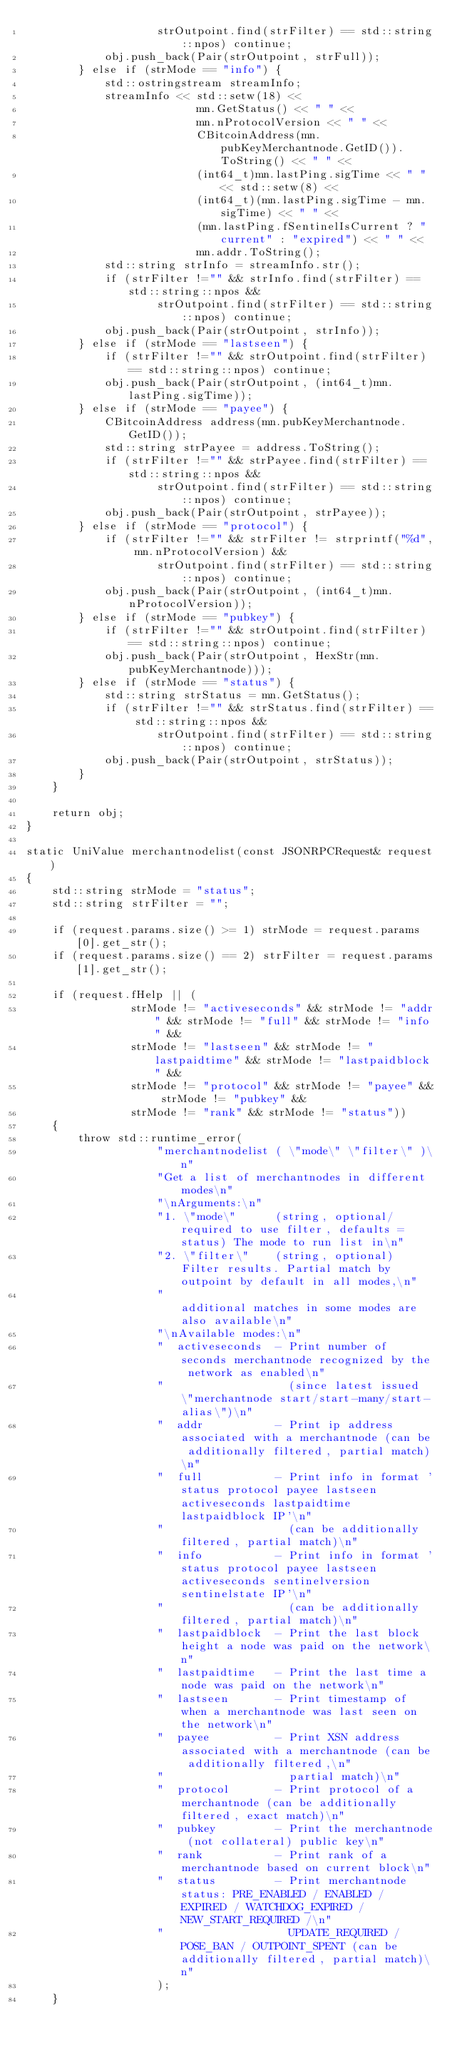<code> <loc_0><loc_0><loc_500><loc_500><_C++_>                    strOutpoint.find(strFilter) == std::string::npos) continue;
            obj.push_back(Pair(strOutpoint, strFull));
        } else if (strMode == "info") {
            std::ostringstream streamInfo;
            streamInfo << std::setw(18) <<
                          mn.GetStatus() << " " <<
                          mn.nProtocolVersion << " " <<
                          CBitcoinAddress(mn.pubKeyMerchantnode.GetID()).ToString() << " " <<
                          (int64_t)mn.lastPing.sigTime << " " << std::setw(8) <<
                          (int64_t)(mn.lastPing.sigTime - mn.sigTime) << " " <<
                          (mn.lastPing.fSentinelIsCurrent ? "current" : "expired") << " " <<
                          mn.addr.ToString();
            std::string strInfo = streamInfo.str();
            if (strFilter !="" && strInfo.find(strFilter) == std::string::npos &&
                    strOutpoint.find(strFilter) == std::string::npos) continue;
            obj.push_back(Pair(strOutpoint, strInfo));
        } else if (strMode == "lastseen") {
            if (strFilter !="" && strOutpoint.find(strFilter) == std::string::npos) continue;
            obj.push_back(Pair(strOutpoint, (int64_t)mn.lastPing.sigTime));
        } else if (strMode == "payee") {
            CBitcoinAddress address(mn.pubKeyMerchantnode.GetID());
            std::string strPayee = address.ToString();
            if (strFilter !="" && strPayee.find(strFilter) == std::string::npos &&
                    strOutpoint.find(strFilter) == std::string::npos) continue;
            obj.push_back(Pair(strOutpoint, strPayee));
        } else if (strMode == "protocol") {
            if (strFilter !="" && strFilter != strprintf("%d", mn.nProtocolVersion) &&
                    strOutpoint.find(strFilter) == std::string::npos) continue;
            obj.push_back(Pair(strOutpoint, (int64_t)mn.nProtocolVersion));
        } else if (strMode == "pubkey") {
            if (strFilter !="" && strOutpoint.find(strFilter) == std::string::npos) continue;
            obj.push_back(Pair(strOutpoint, HexStr(mn.pubKeyMerchantnode)));
        } else if (strMode == "status") {
            std::string strStatus = mn.GetStatus();
            if (strFilter !="" && strStatus.find(strFilter) == std::string::npos &&
                    strOutpoint.find(strFilter) == std::string::npos) continue;
            obj.push_back(Pair(strOutpoint, strStatus));
        }
    }

    return obj;
}

static UniValue merchantnodelist(const JSONRPCRequest& request)
{
    std::string strMode = "status";
    std::string strFilter = "";

    if (request.params.size() >= 1) strMode = request.params[0].get_str();
    if (request.params.size() == 2) strFilter = request.params[1].get_str();

    if (request.fHelp || (
                strMode != "activeseconds" && strMode != "addr" && strMode != "full" && strMode != "info" &&
                strMode != "lastseen" && strMode != "lastpaidtime" && strMode != "lastpaidblock" &&
                strMode != "protocol" && strMode != "payee" && strMode != "pubkey" &&
                strMode != "rank" && strMode != "status"))
    {
        throw std::runtime_error(
                    "merchantnodelist ( \"mode\" \"filter\" )\n"
                    "Get a list of merchantnodes in different modes\n"
                    "\nArguments:\n"
                    "1. \"mode\"      (string, optional/required to use filter, defaults = status) The mode to run list in\n"
                    "2. \"filter\"    (string, optional) Filter results. Partial match by outpoint by default in all modes,\n"
                    "                                    additional matches in some modes are also available\n"
                    "\nAvailable modes:\n"
                    "  activeseconds  - Print number of seconds merchantnode recognized by the network as enabled\n"
                    "                   (since latest issued \"merchantnode start/start-many/start-alias\")\n"
                    "  addr           - Print ip address associated with a merchantnode (can be additionally filtered, partial match)\n"
                    "  full           - Print info in format 'status protocol payee lastseen activeseconds lastpaidtime lastpaidblock IP'\n"
                    "                   (can be additionally filtered, partial match)\n"
                    "  info           - Print info in format 'status protocol payee lastseen activeseconds sentinelversion sentinelstate IP'\n"
                    "                   (can be additionally filtered, partial match)\n"
                    "  lastpaidblock  - Print the last block height a node was paid on the network\n"
                    "  lastpaidtime   - Print the last time a node was paid on the network\n"
                    "  lastseen       - Print timestamp of when a merchantnode was last seen on the network\n"
                    "  payee          - Print XSN address associated with a merchantnode (can be additionally filtered,\n"
                    "                   partial match)\n"
                    "  protocol       - Print protocol of a merchantnode (can be additionally filtered, exact match)\n"
                    "  pubkey         - Print the merchantnode (not collateral) public key\n"
                    "  rank           - Print rank of a merchantnode based on current block\n"
                    "  status         - Print merchantnode status: PRE_ENABLED / ENABLED / EXPIRED / WATCHDOG_EXPIRED / NEW_START_REQUIRED /\n"
                    "                   UPDATE_REQUIRED / POSE_BAN / OUTPOINT_SPENT (can be additionally filtered, partial match)\n"
                    );
    }
</code> 